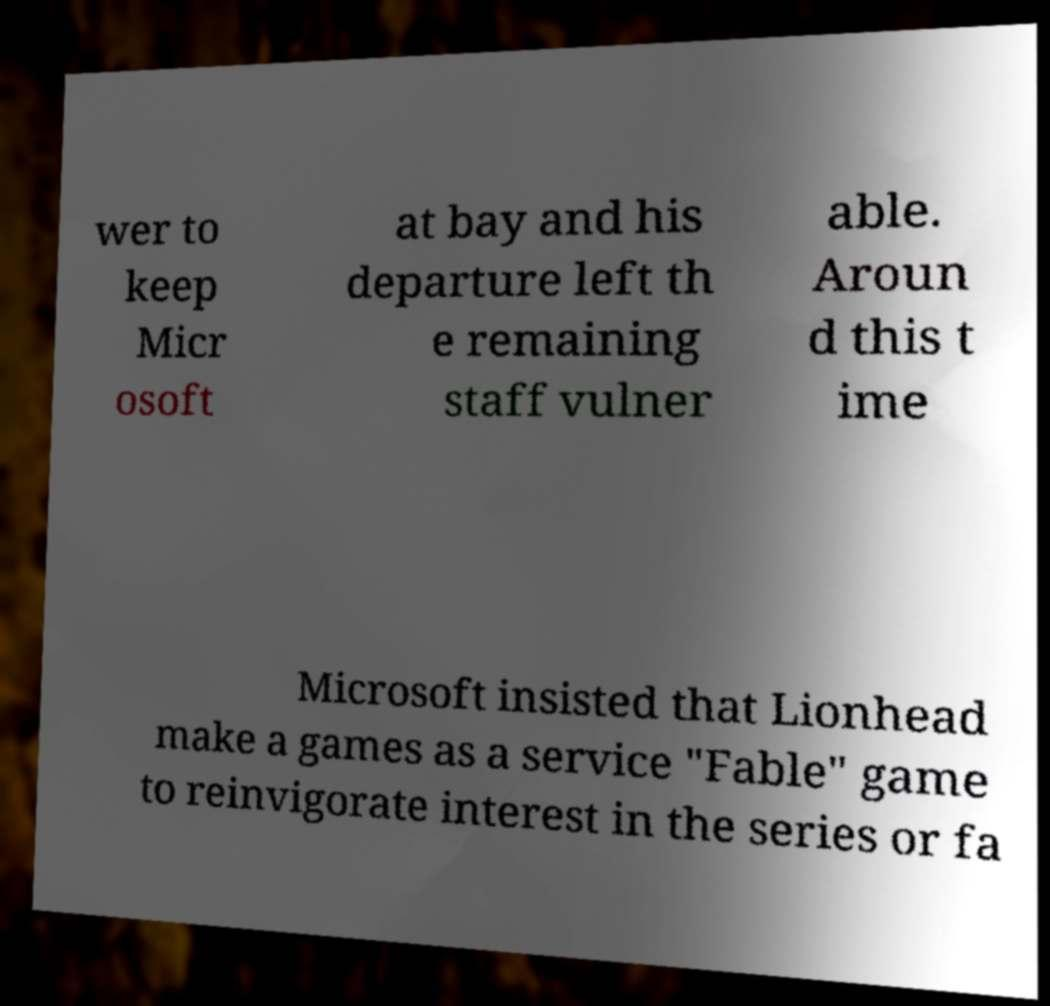For documentation purposes, I need the text within this image transcribed. Could you provide that? wer to keep Micr osoft at bay and his departure left th e remaining staff vulner able. Aroun d this t ime Microsoft insisted that Lionhead make a games as a service "Fable" game to reinvigorate interest in the series or fa 